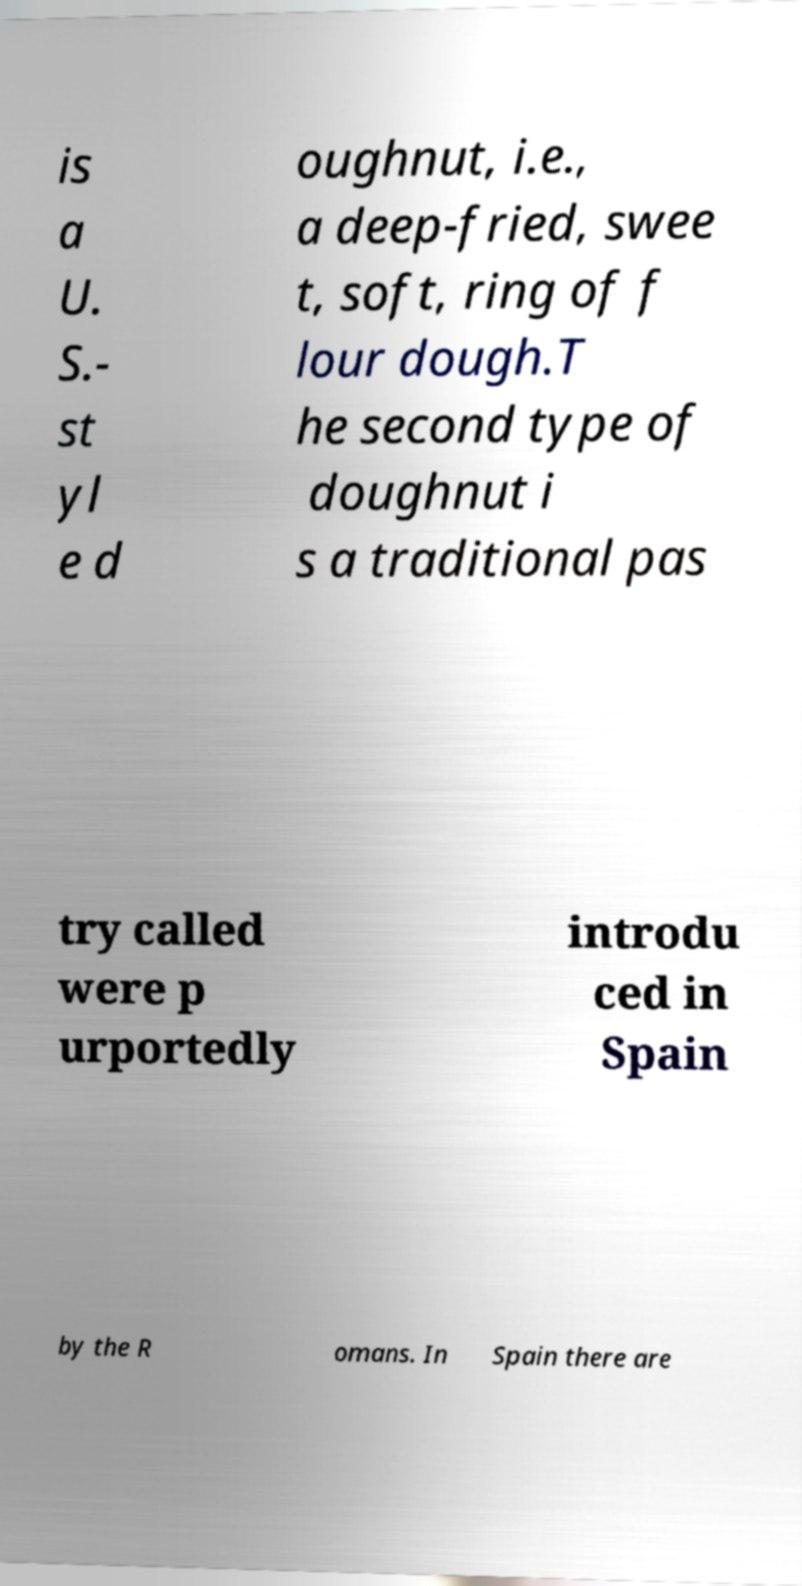For documentation purposes, I need the text within this image transcribed. Could you provide that? is a U. S.- st yl e d oughnut, i.e., a deep-fried, swee t, soft, ring of f lour dough.T he second type of doughnut i s a traditional pas try called were p urportedly introdu ced in Spain by the R omans. In Spain there are 